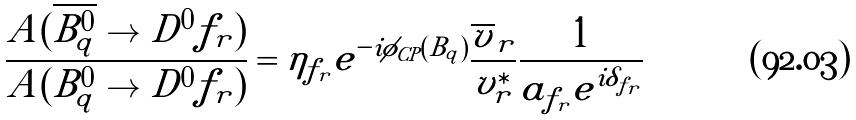<formula> <loc_0><loc_0><loc_500><loc_500>\frac { A ( \overline { { { B _ { q } ^ { 0 } } } } \to D ^ { 0 } f _ { r } ) } { A ( B _ { q } ^ { 0 } \to D ^ { 0 } f _ { r } ) } = \eta _ { f _ { r } } e ^ { - i \phi _ { C P } ( B _ { q } ) } \frac { \overline { v } _ { r } } { v _ { r } ^ { \ast } } \frac { 1 } { a _ { f _ { r } } e ^ { i \delta _ { f _ { r } } } }</formula> 